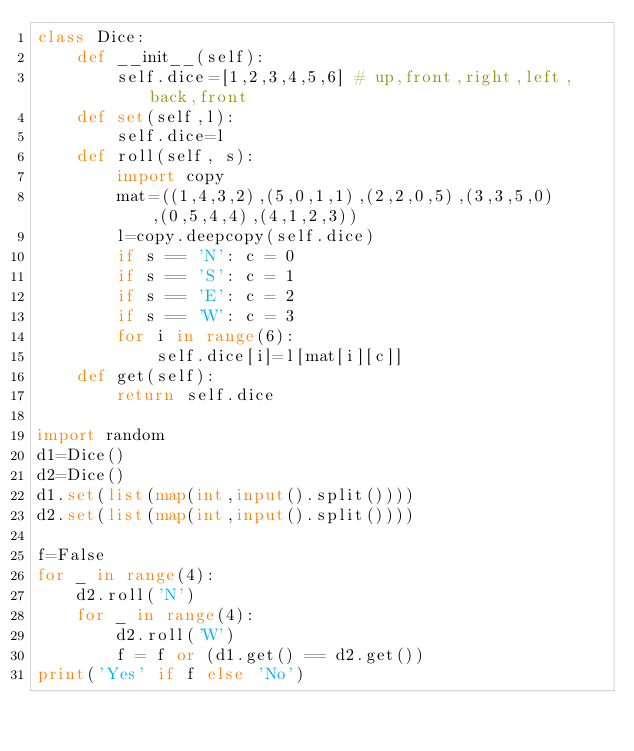Convert code to text. <code><loc_0><loc_0><loc_500><loc_500><_Python_>class Dice:
    def __init__(self):
        self.dice=[1,2,3,4,5,6] # up,front,right,left,back,front
    def set(self,l):
        self.dice=l
    def roll(self, s):
        import copy
        mat=((1,4,3,2),(5,0,1,1),(2,2,0,5),(3,3,5,0),(0,5,4,4),(4,1,2,3))
        l=copy.deepcopy(self.dice)
        if s == 'N': c = 0
        if s == 'S': c = 1
        if s == 'E': c = 2
        if s == 'W': c = 3
        for i in range(6):
            self.dice[i]=l[mat[i][c]]
    def get(self):
        return self.dice

import random
d1=Dice()
d2=Dice()
d1.set(list(map(int,input().split())))
d2.set(list(map(int,input().split())))

f=False
for _ in range(4):
    d2.roll('N')
    for _ in range(4):
        d2.roll('W')
        f = f or (d1.get() == d2.get())
print('Yes' if f else 'No')</code> 